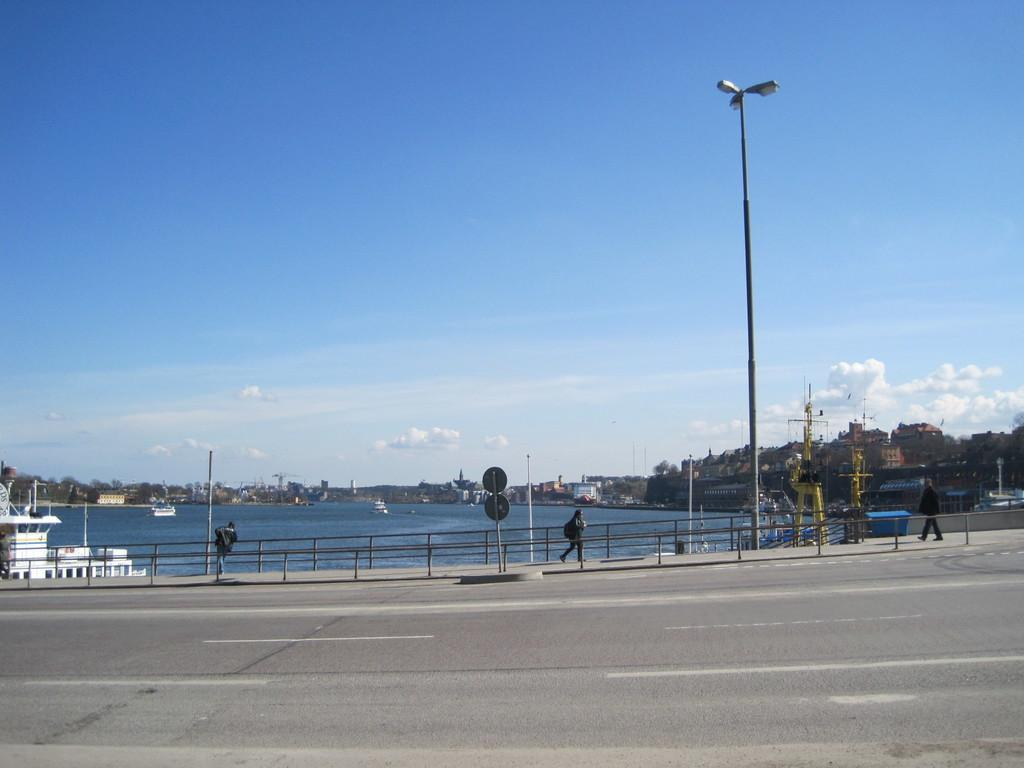What is the main feature of the image? There is a road in the image. What else can be seen along the road? There are poles, people, sign boards, and fencing in the image. What is present near the water in the image? There are boats in the water in the image. What structures are visible in the image? There are buildings in the image. What type of vegetation is present in the image? There are trees in the image. What can be seen in the sky in the image? The sky is visible in the image, and there are clouds in the sky. What type of brush is being used to paint the boundary in the image? There is no brush or painting activity present in the image. What value is assigned to the boundary in the image? There is no mention of a boundary or any value associated with it in the image. 